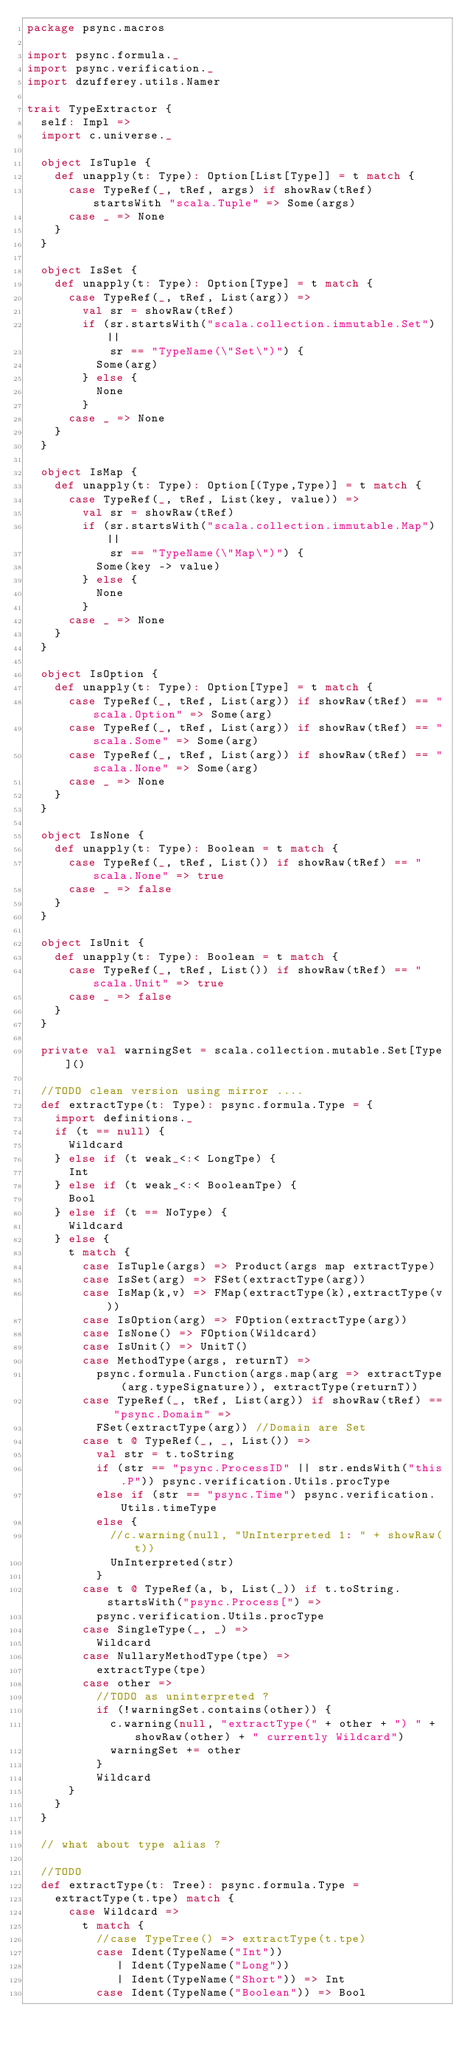<code> <loc_0><loc_0><loc_500><loc_500><_Scala_>package psync.macros

import psync.formula._
import psync.verification._
import dzufferey.utils.Namer

trait TypeExtractor {
  self: Impl =>
  import c.universe._

  object IsTuple {
    def unapply(t: Type): Option[List[Type]] = t match {
      case TypeRef(_, tRef, args) if showRaw(tRef) startsWith "scala.Tuple" => Some(args)
      case _ => None
    }
  }

  object IsSet {
    def unapply(t: Type): Option[Type] = t match {
      case TypeRef(_, tRef, List(arg)) =>
        val sr = showRaw(tRef)
        if (sr.startsWith("scala.collection.immutable.Set") || 
            sr == "TypeName(\"Set\")") {
          Some(arg)
        } else {
          None
        }
      case _ => None
    }
  }

  object IsMap {
    def unapply(t: Type): Option[(Type,Type)] = t match {
      case TypeRef(_, tRef, List(key, value)) =>
        val sr = showRaw(tRef)
        if (sr.startsWith("scala.collection.immutable.Map") || 
            sr == "TypeName(\"Map\")") {
          Some(key -> value)
        } else {
          None
        }
      case _ => None
    }
  }

  object IsOption {
    def unapply(t: Type): Option[Type] = t match {
      case TypeRef(_, tRef, List(arg)) if showRaw(tRef) == "scala.Option" => Some(arg)
      case TypeRef(_, tRef, List(arg)) if showRaw(tRef) == "scala.Some" => Some(arg)
      case TypeRef(_, tRef, List(arg)) if showRaw(tRef) == "scala.None" => Some(arg)
      case _ => None
    }
  }
  
  object IsNone {
    def unapply(t: Type): Boolean = t match {
      case TypeRef(_, tRef, List()) if showRaw(tRef) == "scala.None" => true
      case _ => false
    }
  }

  object IsUnit {
    def unapply(t: Type): Boolean = t match {
      case TypeRef(_, tRef, List()) if showRaw(tRef) == "scala.Unit" => true
      case _ => false
    }
  }

  private val warningSet = scala.collection.mutable.Set[Type]()

  //TODO clean version using mirror ....
  def extractType(t: Type): psync.formula.Type = {
    import definitions._
    if (t == null) {
      Wildcard
    } else if (t weak_<:< LongTpe) {
      Int
    } else if (t weak_<:< BooleanTpe) {
      Bool
    } else if (t == NoType) {
      Wildcard
    } else {
      t match {
        case IsTuple(args) => Product(args map extractType)
        case IsSet(arg) => FSet(extractType(arg))
        case IsMap(k,v) => FMap(extractType(k),extractType(v))
        case IsOption(arg) => FOption(extractType(arg))
        case IsNone() => FOption(Wildcard)
        case IsUnit() => UnitT()
        case MethodType(args, returnT) =>
          psync.formula.Function(args.map(arg => extractType(arg.typeSignature)), extractType(returnT))
        case TypeRef(_, tRef, List(arg)) if showRaw(tRef) == "psync.Domain" =>
          FSet(extractType(arg)) //Domain are Set
        case t @ TypeRef(_, _, List()) =>
          val str = t.toString
          if (str == "psync.ProcessID" || str.endsWith("this.P")) psync.verification.Utils.procType
          else if (str == "psync.Time") psync.verification.Utils.timeType
          else {
            //c.warning(null, "UnInterpreted 1: " + showRaw(t))
            UnInterpreted(str)
          }
        case t @ TypeRef(a, b, List(_)) if t.toString.startsWith("psync.Process[") =>
          psync.verification.Utils.procType
        case SingleType(_, _) =>
          Wildcard
        case NullaryMethodType(tpe) =>
          extractType(tpe)
        case other =>
          //TODO as uninterpreted ?
          if (!warningSet.contains(other)) {
            c.warning(null, "extractType(" + other + ") " + showRaw(other) + " currently Wildcard")
            warningSet += other
          }
          Wildcard
      }
    }
  }
  
  // what about type alias ?
  
  //TODO
  def extractType(t: Tree): psync.formula.Type =
    extractType(t.tpe) match {
      case Wildcard =>
        t match {
          //case TypeTree() => extractType(t.tpe)
          case Ident(TypeName("Int"))
             | Ident(TypeName("Long"))
             | Ident(TypeName("Short")) => Int
          case Ident(TypeName("Boolean")) => Bool</code> 